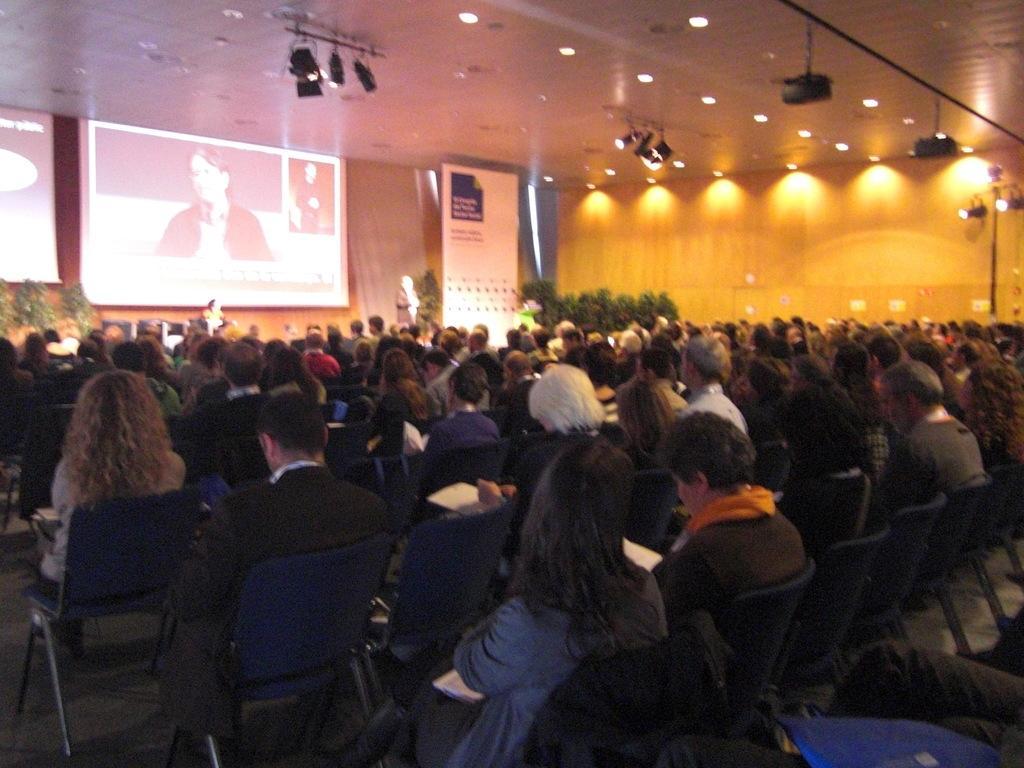How would you summarize this image in a sentence or two? I can see in this image there are group of people who are sitting on a chair and in front of a projector screen. I can also see a person standing beside a banner, here we have few lights. 